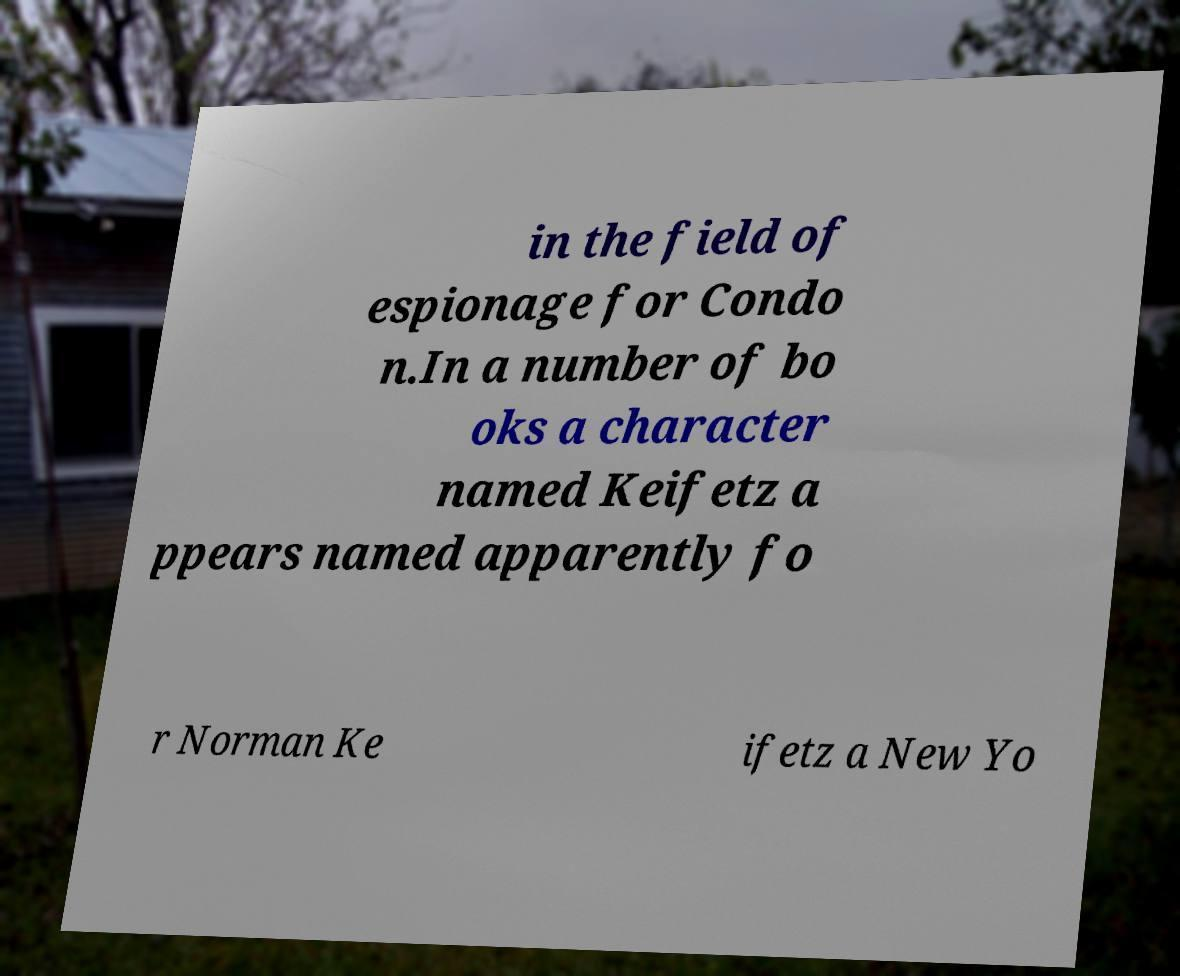Can you accurately transcribe the text from the provided image for me? in the field of espionage for Condo n.In a number of bo oks a character named Keifetz a ppears named apparently fo r Norman Ke ifetz a New Yo 